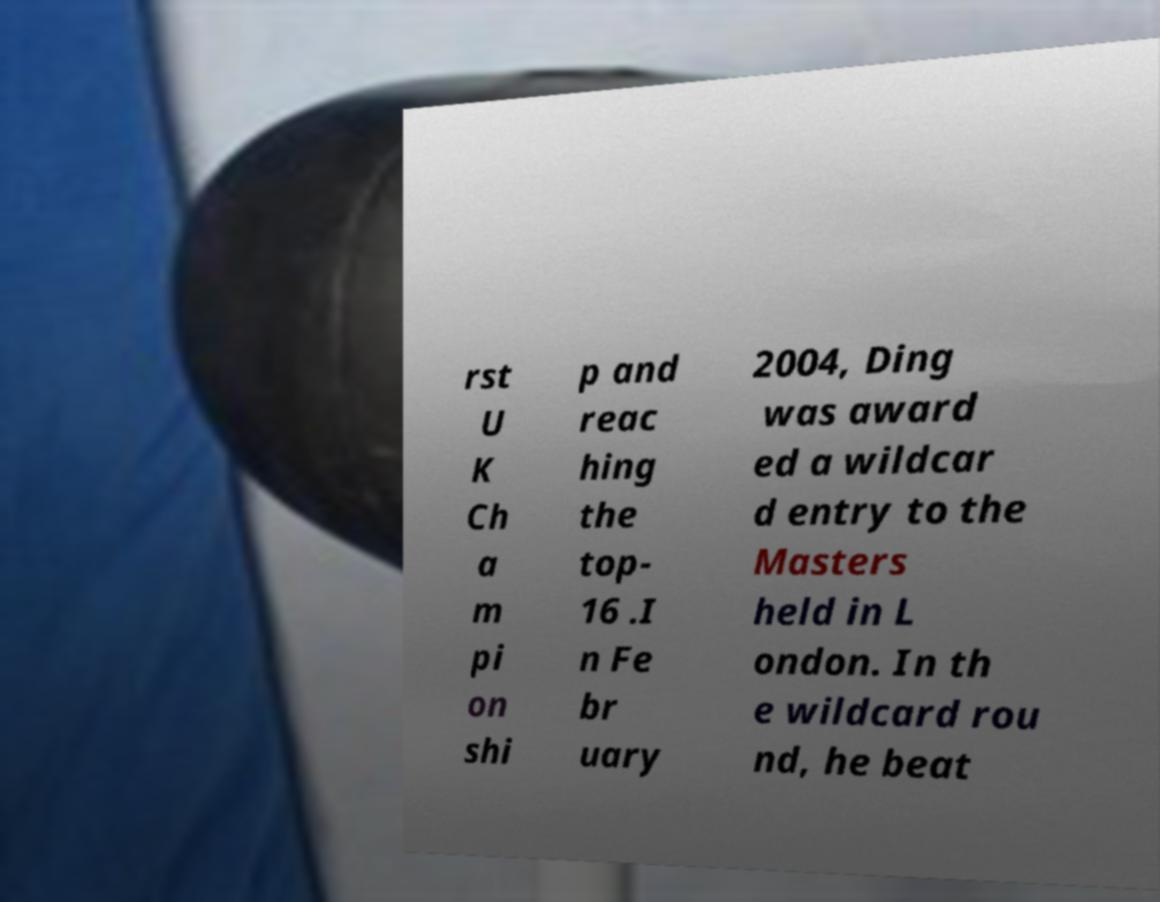What messages or text are displayed in this image? I need them in a readable, typed format. rst U K Ch a m pi on shi p and reac hing the top- 16 .I n Fe br uary 2004, Ding was award ed a wildcar d entry to the Masters held in L ondon. In th e wildcard rou nd, he beat 